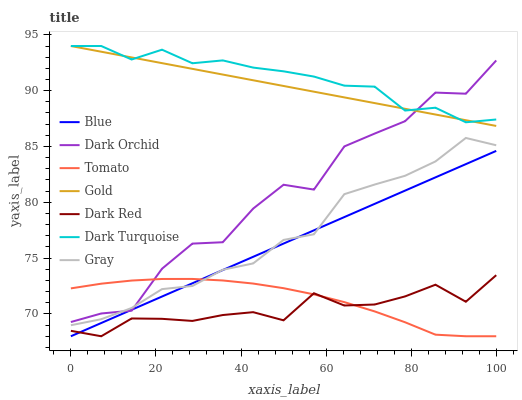Does Dark Red have the minimum area under the curve?
Answer yes or no. Yes. Does Dark Turquoise have the maximum area under the curve?
Answer yes or no. Yes. Does Tomato have the minimum area under the curve?
Answer yes or no. No. Does Tomato have the maximum area under the curve?
Answer yes or no. No. Is Blue the smoothest?
Answer yes or no. Yes. Is Dark Orchid the roughest?
Answer yes or no. Yes. Is Tomato the smoothest?
Answer yes or no. No. Is Tomato the roughest?
Answer yes or no. No. Does Gold have the lowest value?
Answer yes or no. No. Does Dark Turquoise have the highest value?
Answer yes or no. Yes. Does Tomato have the highest value?
Answer yes or no. No. Is Gray less than Gold?
Answer yes or no. Yes. Is Dark Turquoise greater than Blue?
Answer yes or no. Yes. Does Gray intersect Blue?
Answer yes or no. Yes. Is Gray less than Blue?
Answer yes or no. No. Is Gray greater than Blue?
Answer yes or no. No. Does Gray intersect Gold?
Answer yes or no. No. 